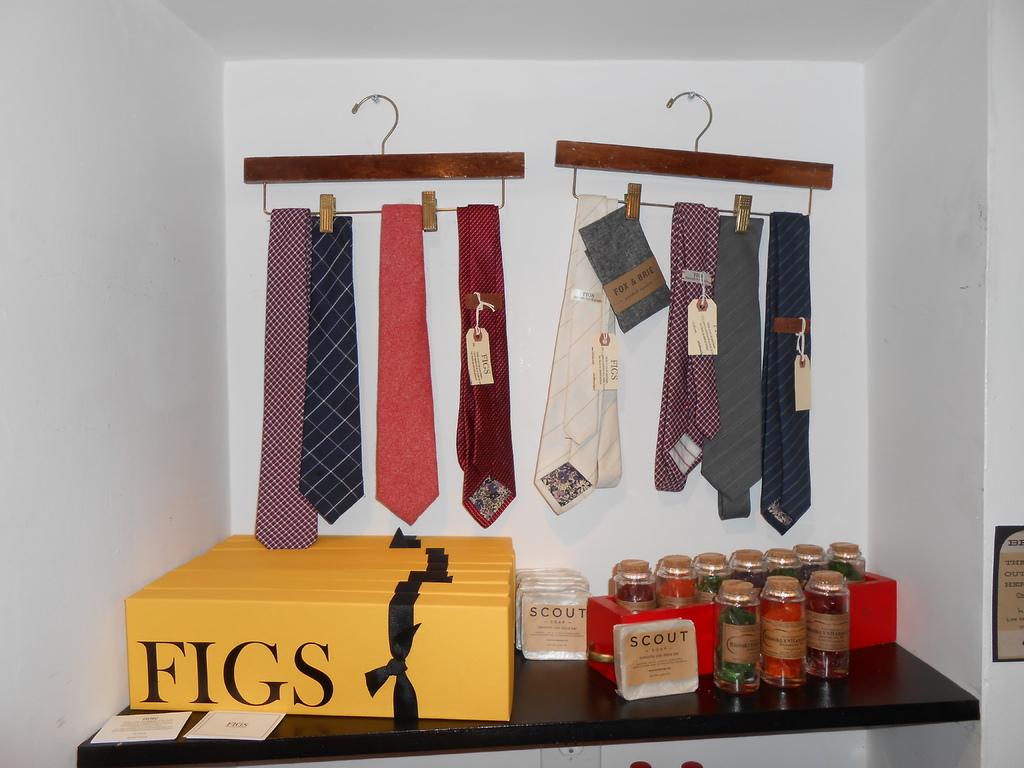What sweet gifts are shown in this photo?
Give a very brief answer. Figs. What does it say on the small white box?
Your response must be concise. Scout. 